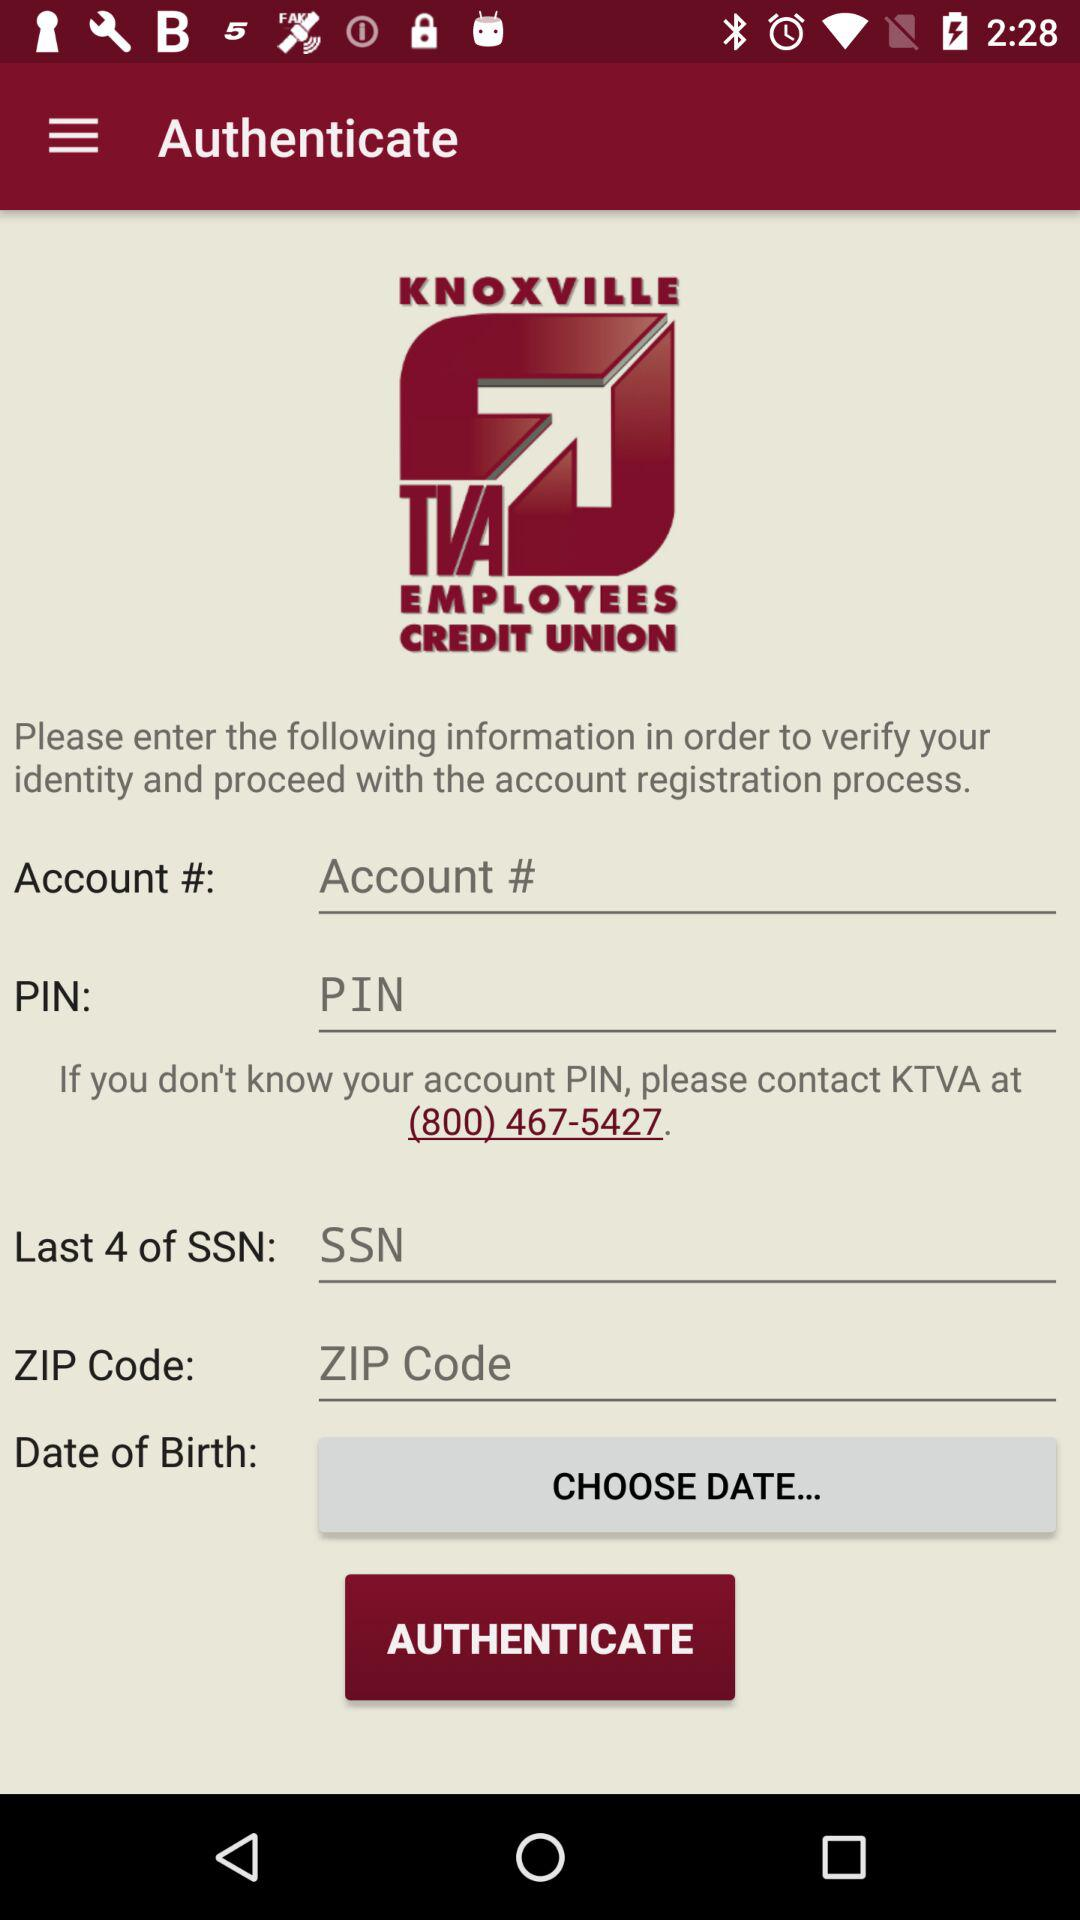How many inputs are required to authenticate?
Answer the question using a single word or phrase. 4 